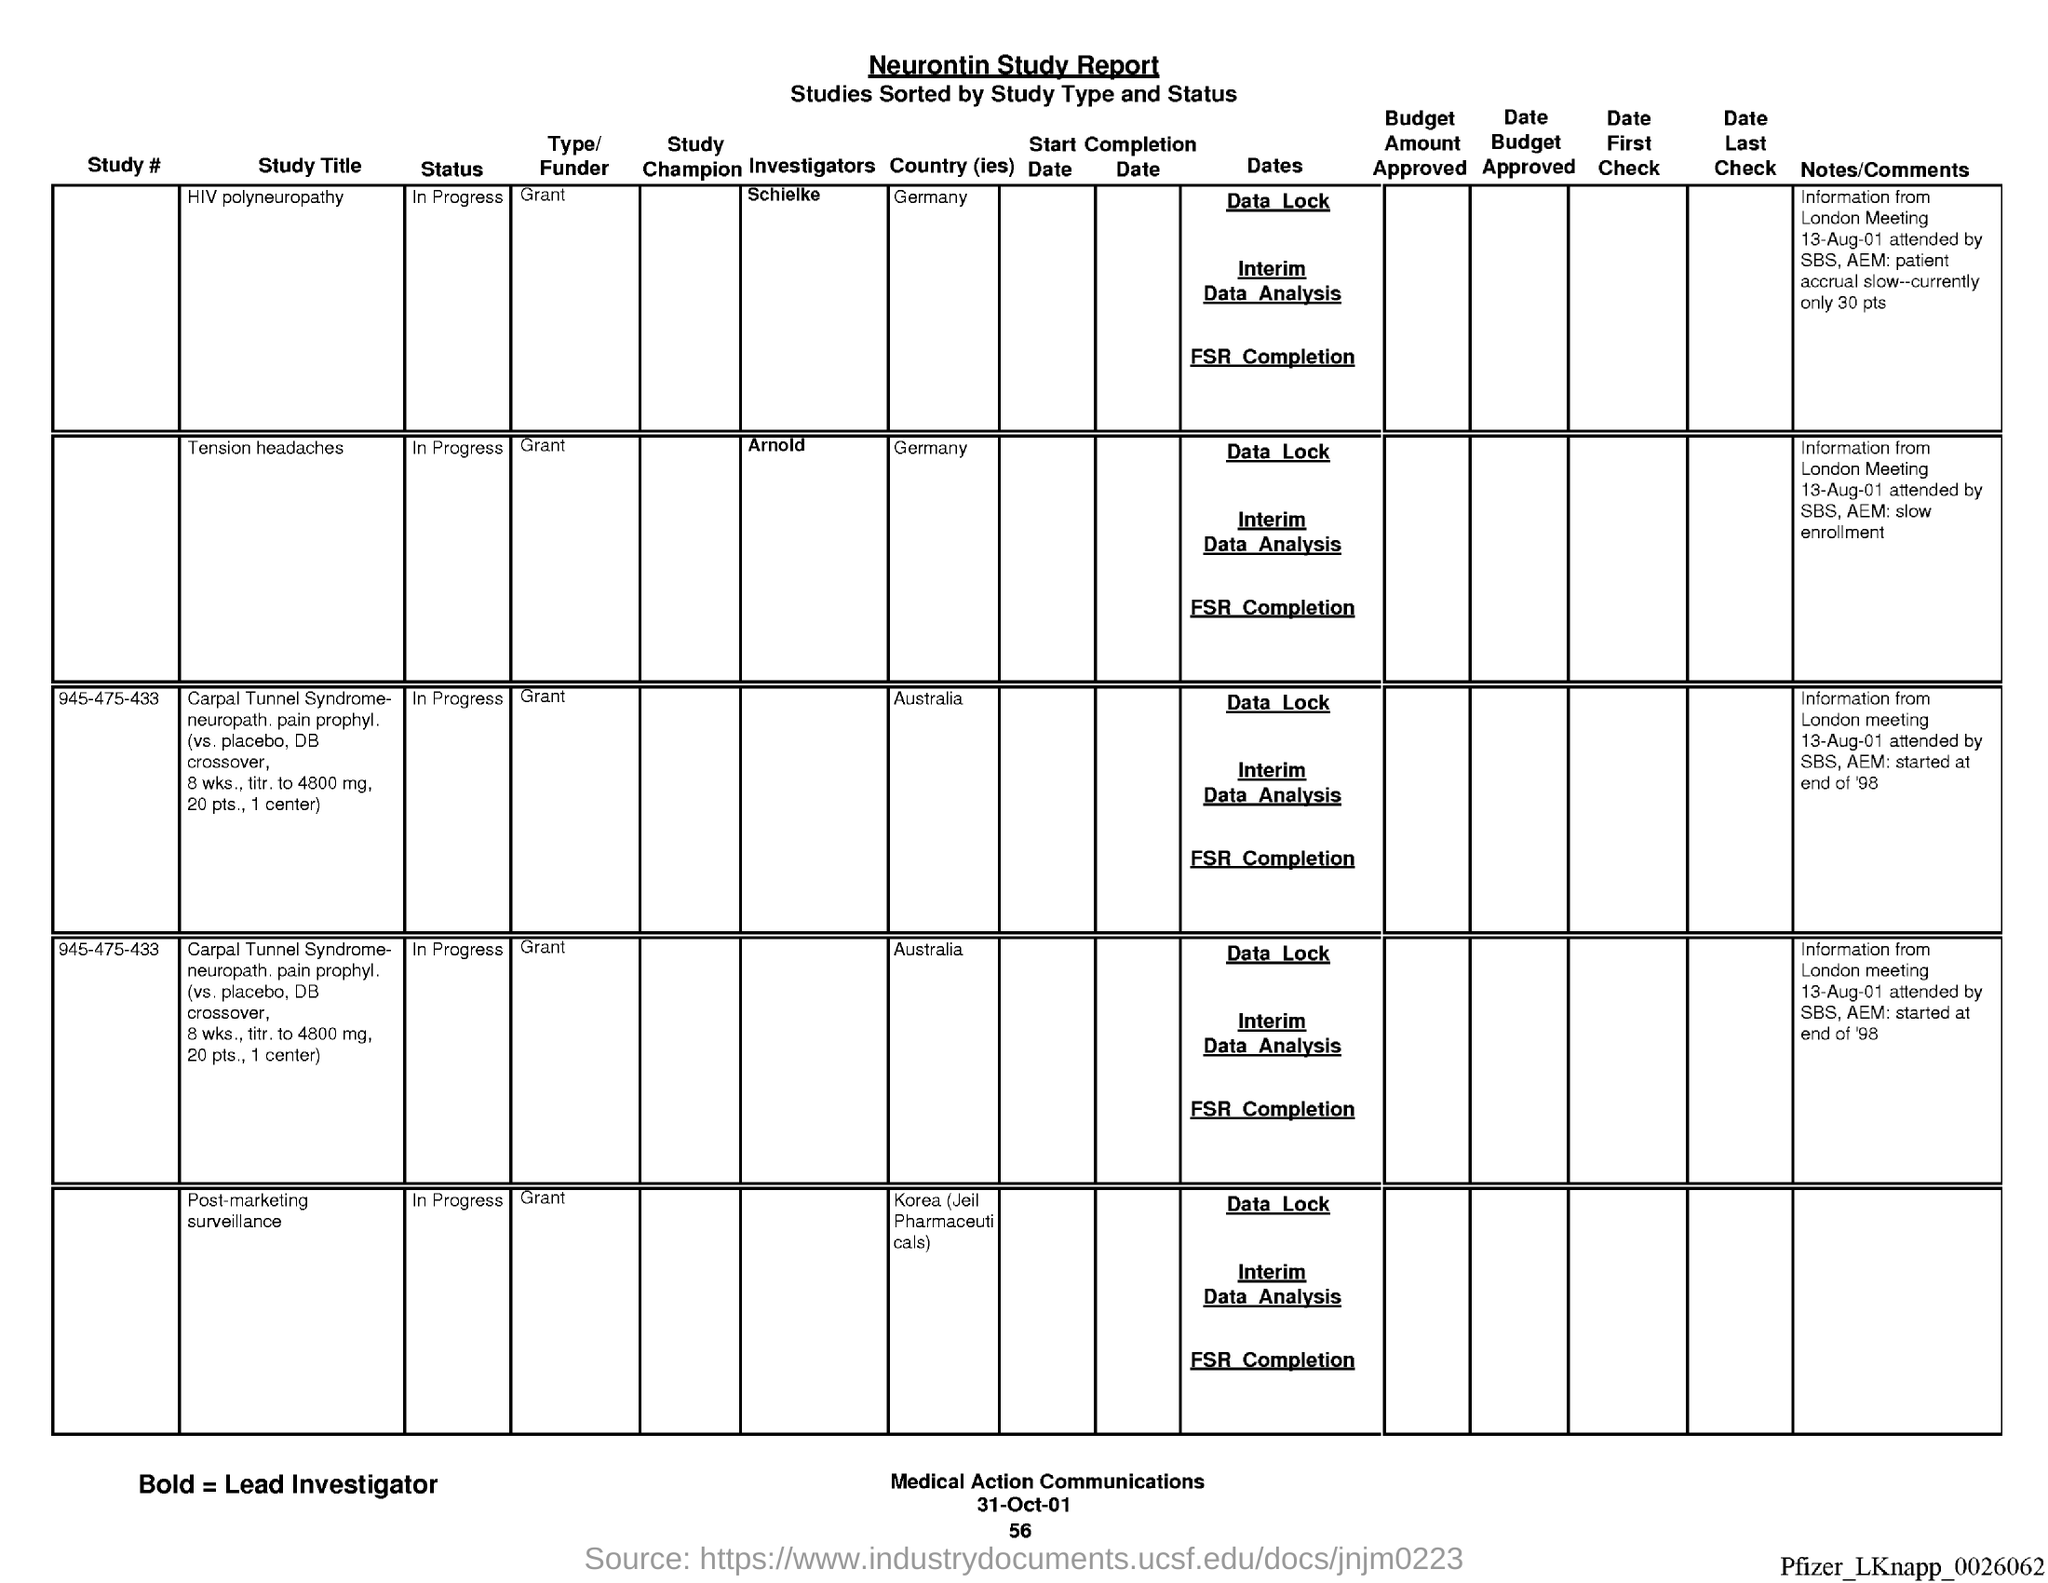Indicate a few pertinent items in this graphic. The study on tension headaches is currently in progress. The country of study for tension headaches is Germany. The study number is Type/Funder of Study #945-475-433, which is a grant. The study "Tension Headaches" is funded by a grant from the grant. The country of study for HIV polyneuropathy is Germany. 